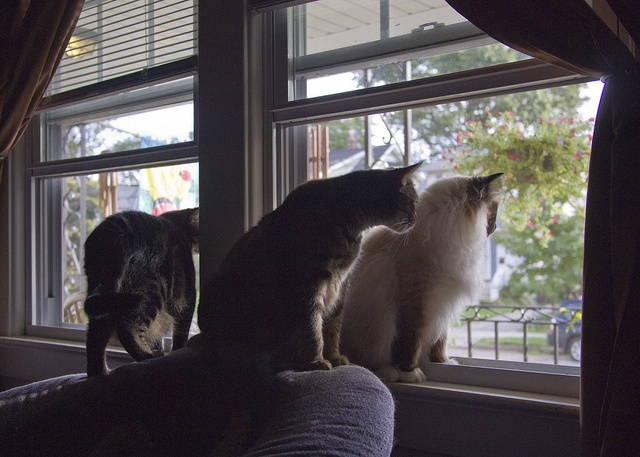Describe the objects in this image and their specific colors. I can see couch in black and gray tones, cat in black, gray, and darkgray tones, cat in black, gray, and darkgray tones, cat in black and gray tones, and car in black, gray, darkgray, and olive tones in this image. 